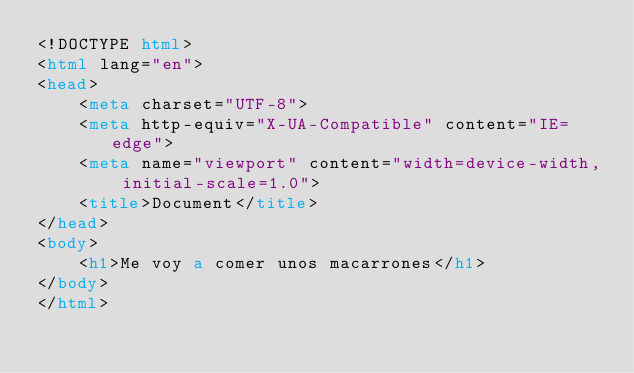Convert code to text. <code><loc_0><loc_0><loc_500><loc_500><_HTML_><!DOCTYPE html>
<html lang="en">
<head>
    <meta charset="UTF-8">
    <meta http-equiv="X-UA-Compatible" content="IE=edge">
    <meta name="viewport" content="width=device-width, initial-scale=1.0">
    <title>Document</title>
</head>
<body>
    <h1>Me voy a comer unos macarrones</h1>
</body>
</html></code> 